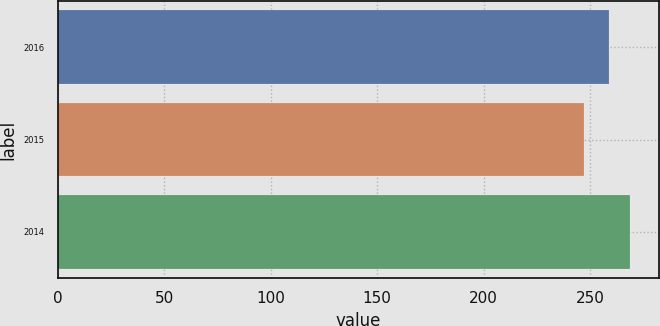<chart> <loc_0><loc_0><loc_500><loc_500><bar_chart><fcel>2016<fcel>2015<fcel>2014<nl><fcel>259<fcel>247<fcel>269<nl></chart> 